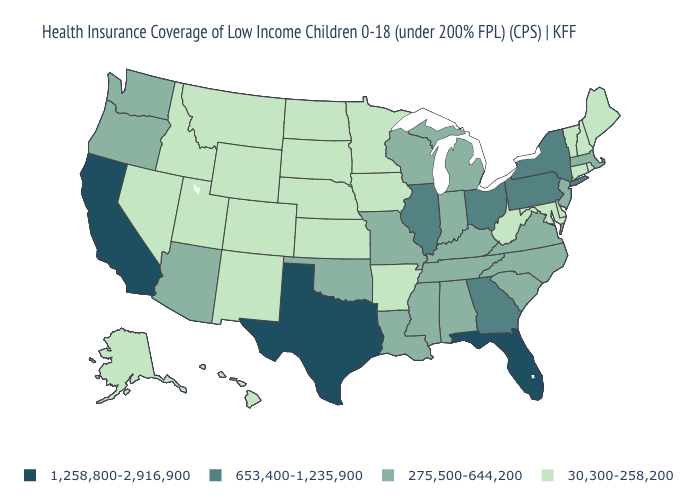Name the states that have a value in the range 653,400-1,235,900?
Answer briefly. Georgia, Illinois, New York, Ohio, Pennsylvania. How many symbols are there in the legend?
Short answer required. 4. Does California have the highest value in the USA?
Concise answer only. Yes. What is the value of Mississippi?
Short answer required. 275,500-644,200. Name the states that have a value in the range 653,400-1,235,900?
Write a very short answer. Georgia, Illinois, New York, Ohio, Pennsylvania. What is the value of Oregon?
Quick response, please. 275,500-644,200. Among the states that border Michigan , which have the highest value?
Short answer required. Ohio. Name the states that have a value in the range 1,258,800-2,916,900?
Keep it brief. California, Florida, Texas. Name the states that have a value in the range 653,400-1,235,900?
Concise answer only. Georgia, Illinois, New York, Ohio, Pennsylvania. Does the first symbol in the legend represent the smallest category?
Write a very short answer. No. Name the states that have a value in the range 1,258,800-2,916,900?
Keep it brief. California, Florida, Texas. Name the states that have a value in the range 1,258,800-2,916,900?
Quick response, please. California, Florida, Texas. Does Washington have the lowest value in the USA?
Concise answer only. No. What is the lowest value in the USA?
Concise answer only. 30,300-258,200. Does Mississippi have the highest value in the USA?
Be succinct. No. 